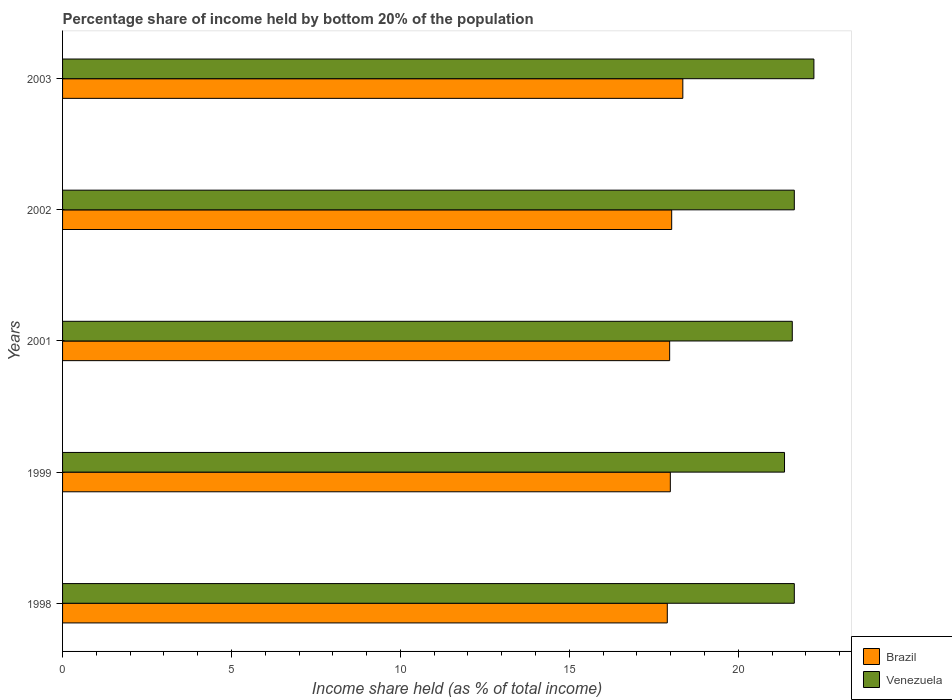Are the number of bars per tick equal to the number of legend labels?
Give a very brief answer. Yes. How many bars are there on the 1st tick from the top?
Ensure brevity in your answer.  2. What is the share of income held by bottom 20% of the population in Brazil in 1999?
Give a very brief answer. 17.99. Across all years, what is the maximum share of income held by bottom 20% of the population in Venezuela?
Provide a short and direct response. 22.24. What is the total share of income held by bottom 20% of the population in Brazil in the graph?
Your answer should be very brief. 90.25. What is the difference between the share of income held by bottom 20% of the population in Venezuela in 1998 and that in 2001?
Keep it short and to the point. 0.06. What is the difference between the share of income held by bottom 20% of the population in Venezuela in 1998 and the share of income held by bottom 20% of the population in Brazil in 1999?
Offer a terse response. 3.67. What is the average share of income held by bottom 20% of the population in Brazil per year?
Make the answer very short. 18.05. In the year 1998, what is the difference between the share of income held by bottom 20% of the population in Brazil and share of income held by bottom 20% of the population in Venezuela?
Keep it short and to the point. -3.76. In how many years, is the share of income held by bottom 20% of the population in Brazil greater than 18 %?
Your response must be concise. 2. What is the ratio of the share of income held by bottom 20% of the population in Venezuela in 1998 to that in 2002?
Offer a very short reply. 1. Is the difference between the share of income held by bottom 20% of the population in Brazil in 1998 and 2002 greater than the difference between the share of income held by bottom 20% of the population in Venezuela in 1998 and 2002?
Provide a short and direct response. No. What is the difference between the highest and the second highest share of income held by bottom 20% of the population in Venezuela?
Give a very brief answer. 0.58. What is the difference between the highest and the lowest share of income held by bottom 20% of the population in Venezuela?
Keep it short and to the point. 0.87. What does the 1st bar from the top in 2003 represents?
Provide a succinct answer. Venezuela. What does the 1st bar from the bottom in 2003 represents?
Make the answer very short. Brazil. What is the difference between two consecutive major ticks on the X-axis?
Provide a short and direct response. 5. Are the values on the major ticks of X-axis written in scientific E-notation?
Keep it short and to the point. No. Does the graph contain any zero values?
Offer a terse response. No. Does the graph contain grids?
Provide a succinct answer. No. How many legend labels are there?
Give a very brief answer. 2. What is the title of the graph?
Ensure brevity in your answer.  Percentage share of income held by bottom 20% of the population. What is the label or title of the X-axis?
Your answer should be compact. Income share held (as % of total income). What is the Income share held (as % of total income) of Venezuela in 1998?
Your response must be concise. 21.66. What is the Income share held (as % of total income) in Brazil in 1999?
Your answer should be very brief. 17.99. What is the Income share held (as % of total income) of Venezuela in 1999?
Give a very brief answer. 21.37. What is the Income share held (as % of total income) in Brazil in 2001?
Offer a terse response. 17.97. What is the Income share held (as % of total income) in Venezuela in 2001?
Offer a terse response. 21.6. What is the Income share held (as % of total income) in Brazil in 2002?
Ensure brevity in your answer.  18.03. What is the Income share held (as % of total income) of Venezuela in 2002?
Your answer should be compact. 21.66. What is the Income share held (as % of total income) of Brazil in 2003?
Your answer should be compact. 18.36. What is the Income share held (as % of total income) in Venezuela in 2003?
Your answer should be compact. 22.24. Across all years, what is the maximum Income share held (as % of total income) of Brazil?
Give a very brief answer. 18.36. Across all years, what is the maximum Income share held (as % of total income) of Venezuela?
Ensure brevity in your answer.  22.24. Across all years, what is the minimum Income share held (as % of total income) in Venezuela?
Offer a very short reply. 21.37. What is the total Income share held (as % of total income) of Brazil in the graph?
Provide a short and direct response. 90.25. What is the total Income share held (as % of total income) of Venezuela in the graph?
Offer a terse response. 108.53. What is the difference between the Income share held (as % of total income) in Brazil in 1998 and that in 1999?
Your answer should be compact. -0.09. What is the difference between the Income share held (as % of total income) of Venezuela in 1998 and that in 1999?
Ensure brevity in your answer.  0.29. What is the difference between the Income share held (as % of total income) in Brazil in 1998 and that in 2001?
Ensure brevity in your answer.  -0.07. What is the difference between the Income share held (as % of total income) in Brazil in 1998 and that in 2002?
Keep it short and to the point. -0.13. What is the difference between the Income share held (as % of total income) of Venezuela in 1998 and that in 2002?
Offer a terse response. 0. What is the difference between the Income share held (as % of total income) of Brazil in 1998 and that in 2003?
Your response must be concise. -0.46. What is the difference between the Income share held (as % of total income) in Venezuela in 1998 and that in 2003?
Provide a succinct answer. -0.58. What is the difference between the Income share held (as % of total income) in Brazil in 1999 and that in 2001?
Offer a terse response. 0.02. What is the difference between the Income share held (as % of total income) of Venezuela in 1999 and that in 2001?
Your answer should be very brief. -0.23. What is the difference between the Income share held (as % of total income) of Brazil in 1999 and that in 2002?
Make the answer very short. -0.04. What is the difference between the Income share held (as % of total income) of Venezuela in 1999 and that in 2002?
Provide a short and direct response. -0.29. What is the difference between the Income share held (as % of total income) in Brazil in 1999 and that in 2003?
Your answer should be very brief. -0.37. What is the difference between the Income share held (as % of total income) of Venezuela in 1999 and that in 2003?
Offer a terse response. -0.87. What is the difference between the Income share held (as % of total income) in Brazil in 2001 and that in 2002?
Ensure brevity in your answer.  -0.06. What is the difference between the Income share held (as % of total income) in Venezuela in 2001 and that in 2002?
Give a very brief answer. -0.06. What is the difference between the Income share held (as % of total income) of Brazil in 2001 and that in 2003?
Offer a very short reply. -0.39. What is the difference between the Income share held (as % of total income) of Venezuela in 2001 and that in 2003?
Ensure brevity in your answer.  -0.64. What is the difference between the Income share held (as % of total income) of Brazil in 2002 and that in 2003?
Your answer should be compact. -0.33. What is the difference between the Income share held (as % of total income) of Venezuela in 2002 and that in 2003?
Provide a short and direct response. -0.58. What is the difference between the Income share held (as % of total income) of Brazil in 1998 and the Income share held (as % of total income) of Venezuela in 1999?
Offer a very short reply. -3.47. What is the difference between the Income share held (as % of total income) in Brazil in 1998 and the Income share held (as % of total income) in Venezuela in 2002?
Ensure brevity in your answer.  -3.76. What is the difference between the Income share held (as % of total income) of Brazil in 1998 and the Income share held (as % of total income) of Venezuela in 2003?
Your response must be concise. -4.34. What is the difference between the Income share held (as % of total income) in Brazil in 1999 and the Income share held (as % of total income) in Venezuela in 2001?
Offer a terse response. -3.61. What is the difference between the Income share held (as % of total income) in Brazil in 1999 and the Income share held (as % of total income) in Venezuela in 2002?
Your response must be concise. -3.67. What is the difference between the Income share held (as % of total income) of Brazil in 1999 and the Income share held (as % of total income) of Venezuela in 2003?
Provide a short and direct response. -4.25. What is the difference between the Income share held (as % of total income) of Brazil in 2001 and the Income share held (as % of total income) of Venezuela in 2002?
Your response must be concise. -3.69. What is the difference between the Income share held (as % of total income) in Brazil in 2001 and the Income share held (as % of total income) in Venezuela in 2003?
Your answer should be very brief. -4.27. What is the difference between the Income share held (as % of total income) in Brazil in 2002 and the Income share held (as % of total income) in Venezuela in 2003?
Ensure brevity in your answer.  -4.21. What is the average Income share held (as % of total income) of Brazil per year?
Provide a succinct answer. 18.05. What is the average Income share held (as % of total income) in Venezuela per year?
Provide a short and direct response. 21.71. In the year 1998, what is the difference between the Income share held (as % of total income) in Brazil and Income share held (as % of total income) in Venezuela?
Provide a succinct answer. -3.76. In the year 1999, what is the difference between the Income share held (as % of total income) of Brazil and Income share held (as % of total income) of Venezuela?
Provide a succinct answer. -3.38. In the year 2001, what is the difference between the Income share held (as % of total income) of Brazil and Income share held (as % of total income) of Venezuela?
Give a very brief answer. -3.63. In the year 2002, what is the difference between the Income share held (as % of total income) in Brazil and Income share held (as % of total income) in Venezuela?
Ensure brevity in your answer.  -3.63. In the year 2003, what is the difference between the Income share held (as % of total income) of Brazil and Income share held (as % of total income) of Venezuela?
Ensure brevity in your answer.  -3.88. What is the ratio of the Income share held (as % of total income) in Venezuela in 1998 to that in 1999?
Give a very brief answer. 1.01. What is the ratio of the Income share held (as % of total income) in Venezuela in 1998 to that in 2001?
Give a very brief answer. 1. What is the ratio of the Income share held (as % of total income) of Brazil in 1998 to that in 2002?
Ensure brevity in your answer.  0.99. What is the ratio of the Income share held (as % of total income) in Venezuela in 1998 to that in 2002?
Offer a terse response. 1. What is the ratio of the Income share held (as % of total income) in Brazil in 1998 to that in 2003?
Make the answer very short. 0.97. What is the ratio of the Income share held (as % of total income) of Venezuela in 1998 to that in 2003?
Your answer should be compact. 0.97. What is the ratio of the Income share held (as % of total income) in Venezuela in 1999 to that in 2002?
Your answer should be very brief. 0.99. What is the ratio of the Income share held (as % of total income) of Brazil in 1999 to that in 2003?
Provide a short and direct response. 0.98. What is the ratio of the Income share held (as % of total income) in Venezuela in 1999 to that in 2003?
Ensure brevity in your answer.  0.96. What is the ratio of the Income share held (as % of total income) in Brazil in 2001 to that in 2002?
Offer a very short reply. 1. What is the ratio of the Income share held (as % of total income) of Brazil in 2001 to that in 2003?
Your answer should be compact. 0.98. What is the ratio of the Income share held (as % of total income) of Venezuela in 2001 to that in 2003?
Your response must be concise. 0.97. What is the ratio of the Income share held (as % of total income) in Venezuela in 2002 to that in 2003?
Keep it short and to the point. 0.97. What is the difference between the highest and the second highest Income share held (as % of total income) in Brazil?
Your response must be concise. 0.33. What is the difference between the highest and the second highest Income share held (as % of total income) of Venezuela?
Offer a terse response. 0.58. What is the difference between the highest and the lowest Income share held (as % of total income) of Brazil?
Ensure brevity in your answer.  0.46. What is the difference between the highest and the lowest Income share held (as % of total income) of Venezuela?
Offer a very short reply. 0.87. 